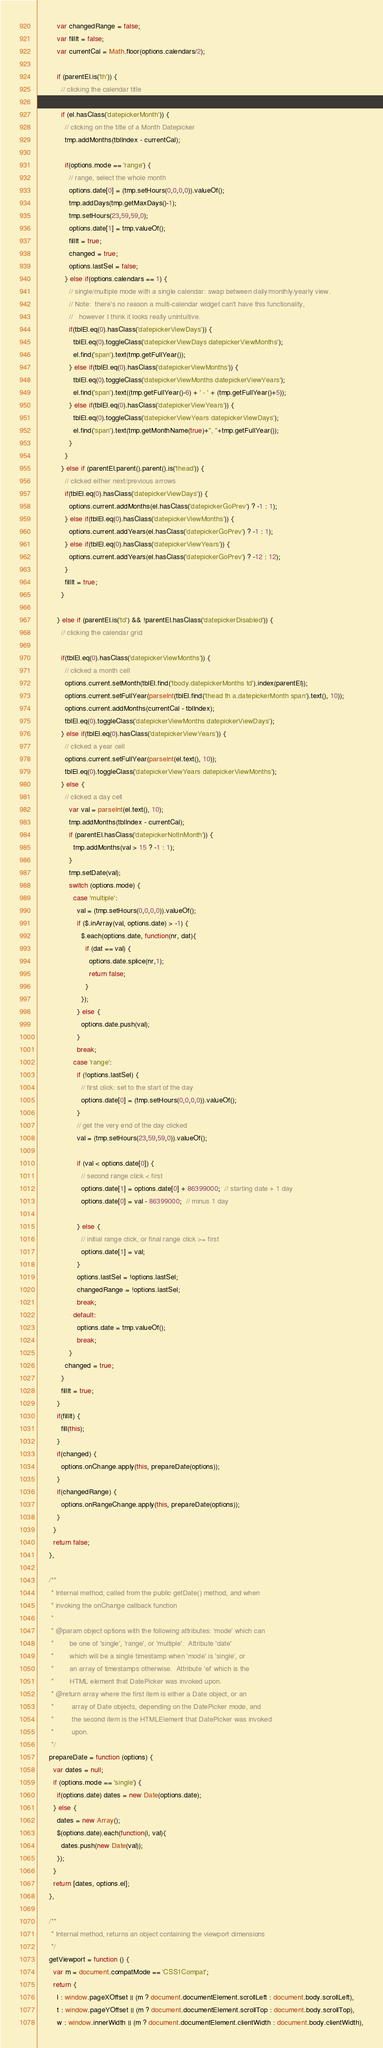<code> <loc_0><loc_0><loc_500><loc_500><_JavaScript_>          var changedRange = false;
          var fillIt = false;
          var currentCal = Math.floor(options.calendars/2);
          
          if (parentEl.is('th')) {
            // clicking the calendar title
            
            if (el.hasClass('datepickerMonth')) {
              // clicking on the title of a Month Datepicker
              tmp.addMonths(tblIndex - currentCal);
              
              if(options.mode == 'range') {
                // range, select the whole month
                options.date[0] = (tmp.setHours(0,0,0,0)).valueOf();
                tmp.addDays(tmp.getMaxDays()-1);
                tmp.setHours(23,59,59,0);
                options.date[1] = tmp.valueOf();
                fillIt = true;
                changed = true;
                options.lastSel = false;
              } else if(options.calendars == 1) {
                // single/multiple mode with a single calendar: swap between daily/monthly/yearly view.
                // Note:  there's no reason a multi-calendar widget can't have this functionality,
                //   however I think it looks really unintuitive.
                if(tblEl.eq(0).hasClass('datepickerViewDays')) {
                  tblEl.eq(0).toggleClass('datepickerViewDays datepickerViewMonths');
                  el.find('span').text(tmp.getFullYear());
                } else if(tblEl.eq(0).hasClass('datepickerViewMonths')) {
                  tblEl.eq(0).toggleClass('datepickerViewMonths datepickerViewYears');
                  el.find('span').text((tmp.getFullYear()-6) + ' - ' + (tmp.getFullYear()+5));
                } else if(tblEl.eq(0).hasClass('datepickerViewYears')) {
                  tblEl.eq(0).toggleClass('datepickerViewYears datepickerViewDays');
                  el.find('span').text(tmp.getMonthName(true)+", "+tmp.getFullYear());
                }
              }
            } else if (parentEl.parent().parent().is('thead')) {
              // clicked either next/previous arrows
              if(tblEl.eq(0).hasClass('datepickerViewDays')) {
                options.current.addMonths(el.hasClass('datepickerGoPrev') ? -1 : 1);
              } else if(tblEl.eq(0).hasClass('datepickerViewMonths')) {
                options.current.addYears(el.hasClass('datepickerGoPrev') ? -1 : 1);
              } else if(tblEl.eq(0).hasClass('datepickerViewYears')) {
                options.current.addYears(el.hasClass('datepickerGoPrev') ? -12 : 12);
              }
              fillIt = true;
            }
            
          } else if (parentEl.is('td') && !parentEl.hasClass('datepickerDisabled')) {
            // clicking the calendar grid
            
            if(tblEl.eq(0).hasClass('datepickerViewMonths')) {
              // clicked a month cell
              options.current.setMonth(tblEl.find('tbody.datepickerMonths td').index(parentEl));
              options.current.setFullYear(parseInt(tblEl.find('thead th a.datepickerMonth span').text(), 10));
              options.current.addMonths(currentCal - tblIndex);
              tblEl.eq(0).toggleClass('datepickerViewMonths datepickerViewDays');
            } else if(tblEl.eq(0).hasClass('datepickerViewYears')) {
              // clicked a year cell
              options.current.setFullYear(parseInt(el.text(), 10));
              tblEl.eq(0).toggleClass('datepickerViewYears datepickerViewMonths');
            } else {
              // clicked a day cell
                var val = parseInt(el.text(), 10);
                tmp.addMonths(tblIndex - currentCal);
                if (parentEl.hasClass('datepickerNotInMonth')) {
                  tmp.addMonths(val > 15 ? -1 : 1);
                }
                tmp.setDate(val);
                switch (options.mode) {
                  case 'multiple':
                    val = (tmp.setHours(0,0,0,0)).valueOf();
                    if ($.inArray(val, options.date) > -1) {
                      $.each(options.date, function(nr, dat){
                        if (dat == val) {
                          options.date.splice(nr,1);
                          return false;
                        }
                      });
                    } else {
                      options.date.push(val);
                    }
                    break;
                  case 'range':
                    if (!options.lastSel) {
                      // first click: set to the start of the day
                      options.date[0] = (tmp.setHours(0,0,0,0)).valueOf();
                    }
                    // get the very end of the day clicked
                    val = (tmp.setHours(23,59,59,0)).valueOf();
                    
                    if (val < options.date[0]) {
                      // second range click < first
                      options.date[1] = options.date[0] + 86399000;  // starting date + 1 day
                      options.date[0] = val - 86399000;  // minus 1 day

                    } else {
                      // initial range click, or final range click >= first
                      options.date[1] = val;
                    }
                    options.lastSel = !options.lastSel;
                    changedRange = !options.lastSel;
                    break;
                  default:
                    options.date = tmp.valueOf();
                    break;
                }
              changed = true;
            }
            fillIt = true;
          }
          if(fillIt) {
            fill(this);
          }
          if(changed) {
            options.onChange.apply(this, prepareDate(options));
          }
          if(changedRange) {
            options.onRangeChange.apply(this, prepareDate(options));
          }
        }
        return false;
      },
      
      /**
       * Internal method, called from the public getDate() method, and when
       * invoking the onChange callback function
       * 
       * @param object options with the following attributes: 'mode' which can
       *        be one of 'single', 'range', or 'multiple'.  Attribute 'date'
       *        which will be a single timestamp when 'mode' is 'single', or
       *        an array of timestamps otherwise.  Attribute 'el' which is the
       *        HTML element that DatePicker was invoked upon.
       * @return array where the first item is either a Date object, or an 
       *         array of Date objects, depending on the DatePicker mode, and
       *         the second item is the HTMLElement that DatePicker was invoked
       *         upon.
       */
      prepareDate = function (options) {
        var dates = null;
        if (options.mode == 'single') {
          if(options.date) dates = new Date(options.date);
        } else {
          dates = new Array();
          $(options.date).each(function(i, val){
            dates.push(new Date(val));
          });
        }
        return [dates, options.el];
      },
      
      /**
       * Internal method, returns an object containing the viewport dimensions
       */
      getViewport = function () {
        var m = document.compatMode == 'CSS1Compat';
        return {
          l : window.pageXOffset || (m ? document.documentElement.scrollLeft : document.body.scrollLeft),
          t : window.pageYOffset || (m ? document.documentElement.scrollTop : document.body.scrollTop),
          w : window.innerWidth || (m ? document.documentElement.clientWidth : document.body.clientWidth),</code> 